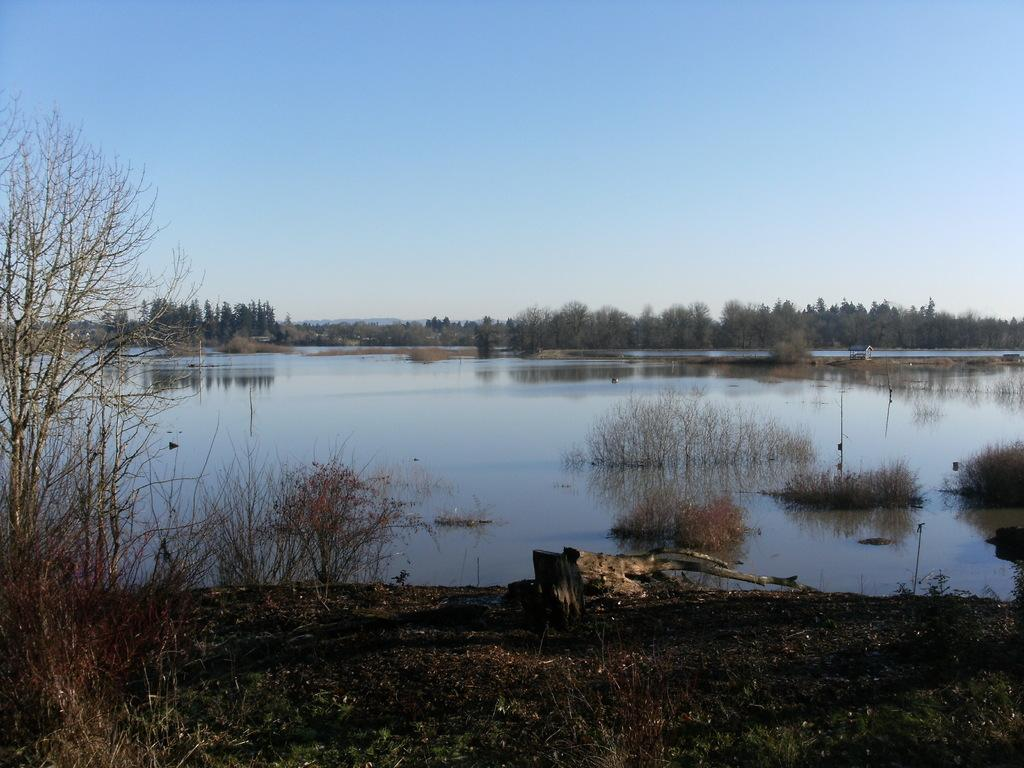What type of landscape is depicted at the bottom of the image? There is grassland at the bottom side of the image. What can be seen in the center of the image? There is water in the center of the image. What type of vegetation is visible in the background of the image? There are trees in the background area of the image. Where is the cave located in the image? There is no cave present in the image. Can you see any chess pieces on the grassland? There are no chess pieces visible in the image. 